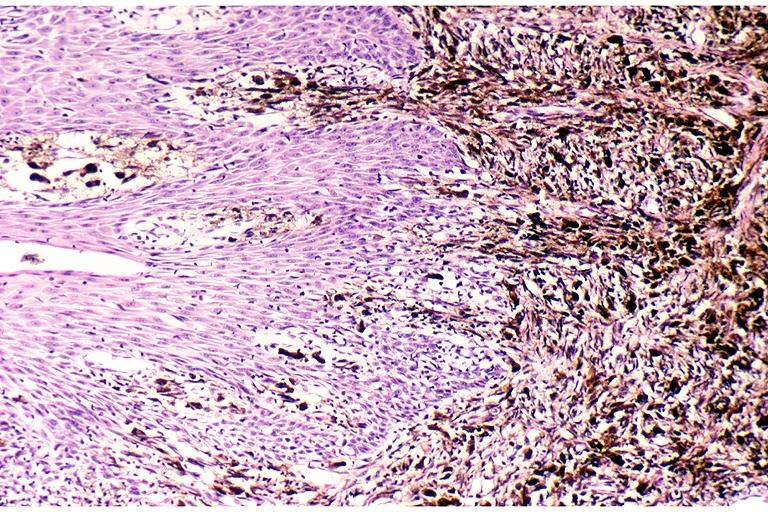does this image show melanoma?
Answer the question using a single word or phrase. Yes 